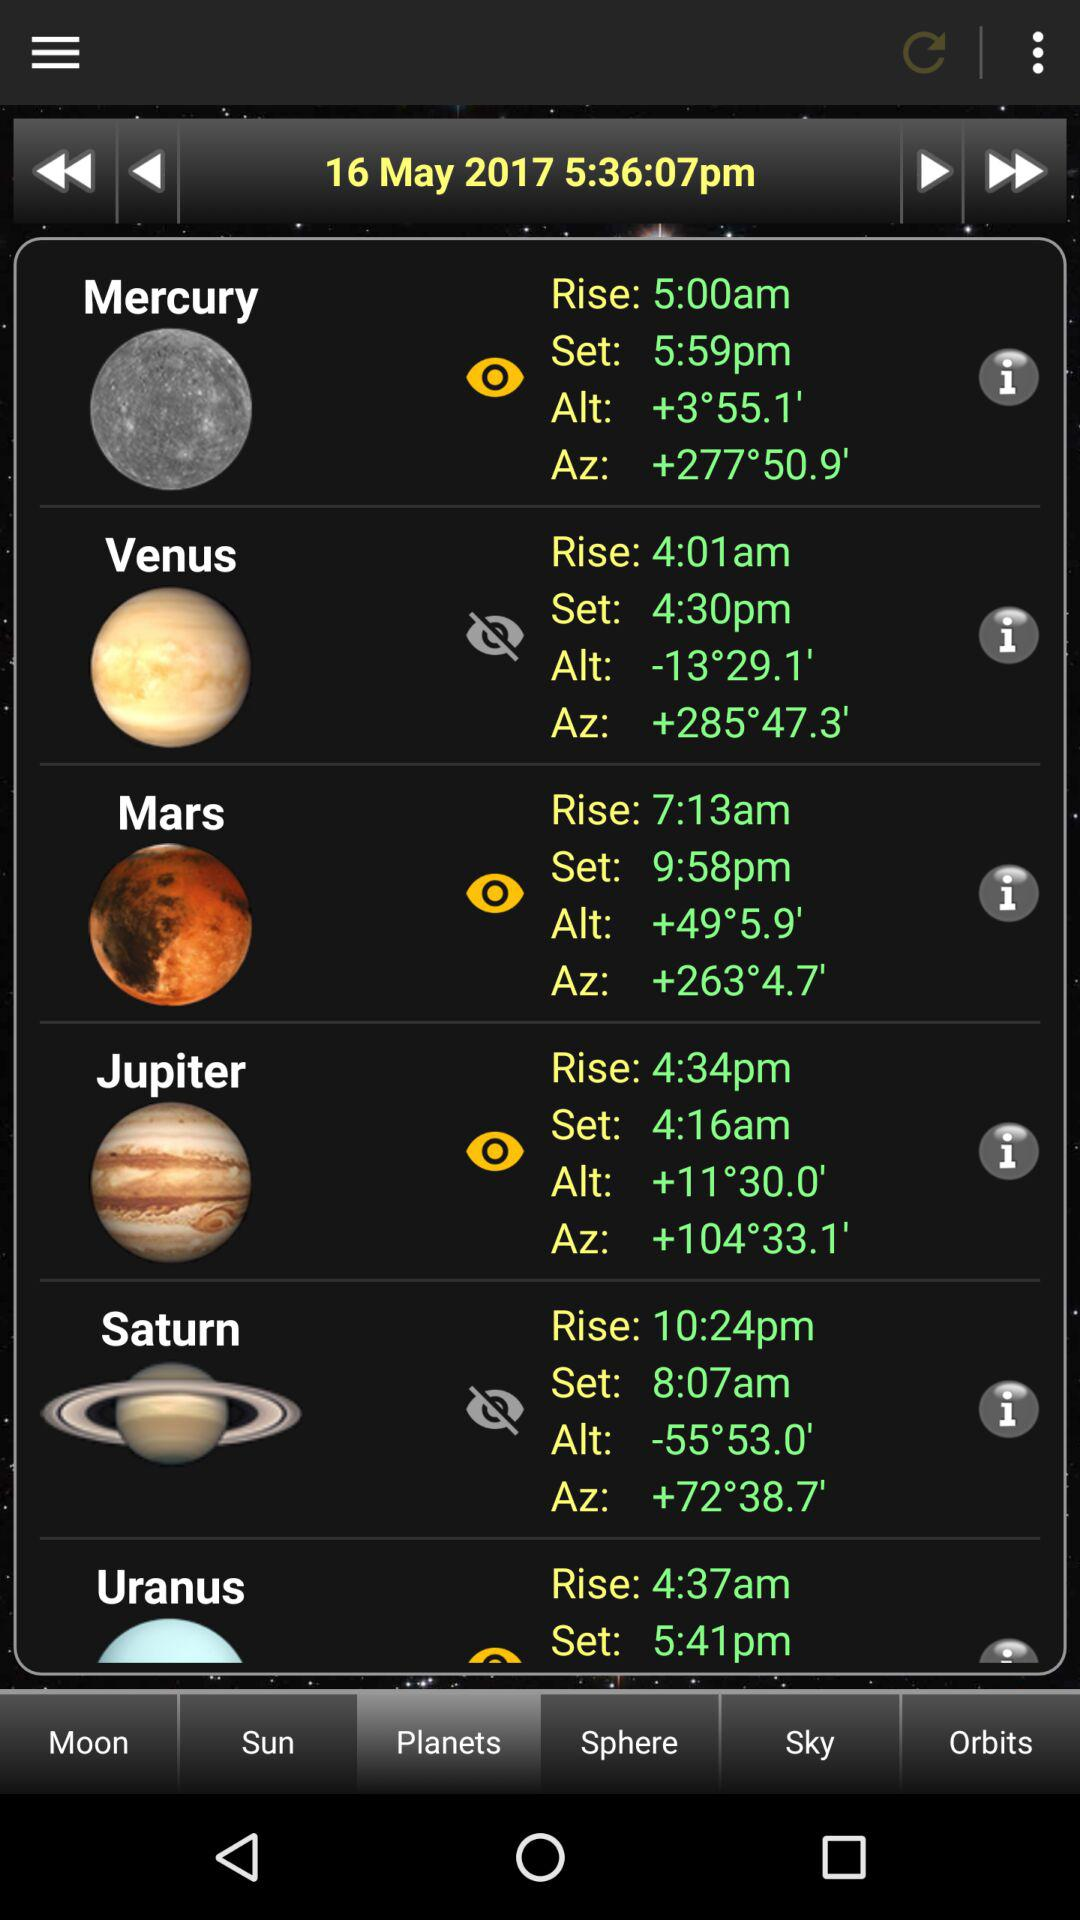What is the date? The date is May 16, 2017. 